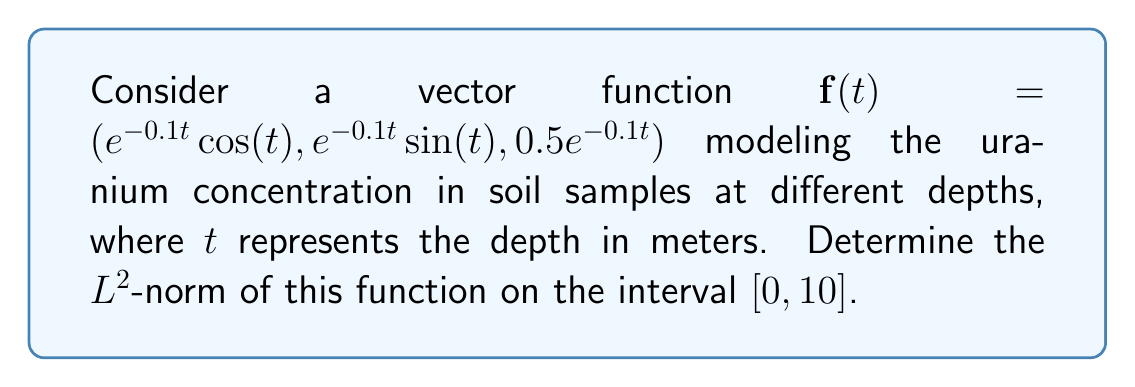Can you answer this question? To solve this problem, we'll follow these steps:

1) The $L^2$-norm of a vector function $\mathbf{f}(t)$ on an interval $[a,b]$ is defined as:

   $$\|\mathbf{f}\|_2 = \sqrt{\int_a^b |\mathbf{f}(t)|^2 dt}$$

2) In our case, $|\mathbf{f}(t)|^2$ is the dot product of $\mathbf{f}(t)$ with itself:

   $$|\mathbf{f}(t)|^2 = (e^{-0.1t}\cos(t))^2 + (e^{-0.1t}\sin(t))^2 + (0.5e^{-0.1t})^2$$

3) Simplify using the trigonometric identity $\cos^2(t) + \sin^2(t) = 1$:

   $$|\mathbf{f}(t)|^2 = e^{-0.2t} + 0.25e^{-0.2t} = 1.25e^{-0.2t}$$

4) Now we need to calculate:

   $$\|\mathbf{f}\|_2 = \sqrt{\int_0^{10} 1.25e^{-0.2t} dt}$$

5) Integrate:

   $$\int_0^{10} 1.25e^{-0.2t} dt = -6.25[e^{-0.2t}]_0^{10} = -6.25(e^{-2} - 1) = 6.25(1 - e^{-2})$$

6) Take the square root:

   $$\|\mathbf{f}\|_2 = \sqrt{6.25(1 - e^{-2})} = \sqrt{6.25} \sqrt{1 - e^{-2}} = 2.5 \sqrt{1 - e^{-2}}$$
Answer: The $L^2$-norm of the vector function is $2.5 \sqrt{1 - e^{-2}} \approx 2.3979$. 